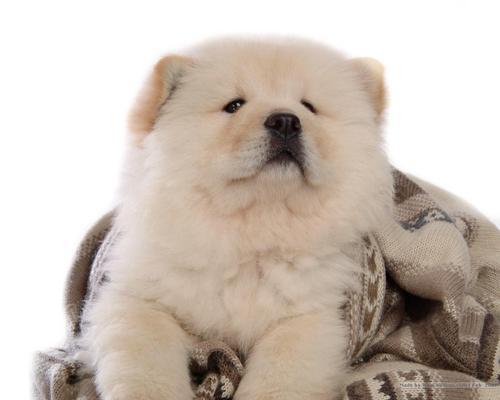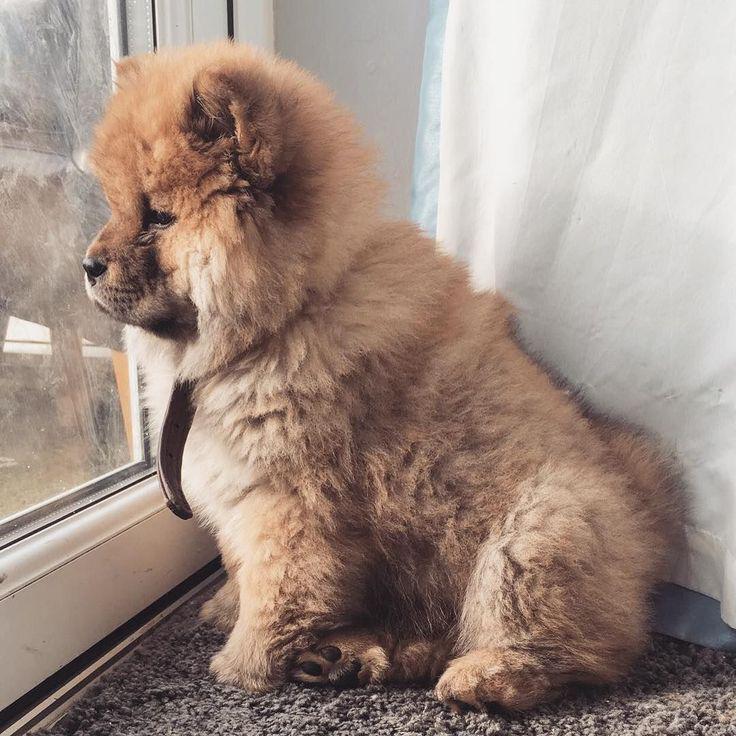The first image is the image on the left, the second image is the image on the right. Analyze the images presented: Is the assertion "One of the images shows at least two dogs." valid? Answer yes or no. No. The first image is the image on the left, the second image is the image on the right. Assess this claim about the two images: "There are two dogs". Correct or not? Answer yes or no. Yes. 